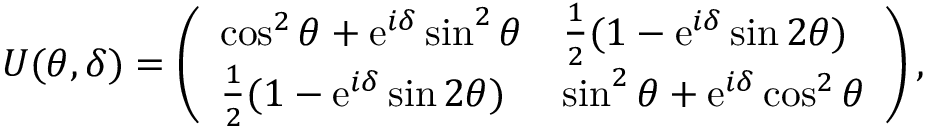Convert formula to latex. <formula><loc_0><loc_0><loc_500><loc_500>U ( \theta , \delta ) = \left ( \begin{array} { l l } { \cos ^ { 2 } { \theta } + e ^ { i \delta } \sin ^ { 2 } { \theta } } & { \frac { 1 } { 2 } ( 1 - e ^ { i \delta } \sin { 2 \theta } ) } \\ { \frac { 1 } { 2 } ( 1 - e ^ { i \delta } \sin { 2 \theta } ) } & { \sin ^ { 2 } { \theta } + e ^ { i \delta } \cos ^ { 2 } { \theta } } \end{array} \right ) ,</formula> 